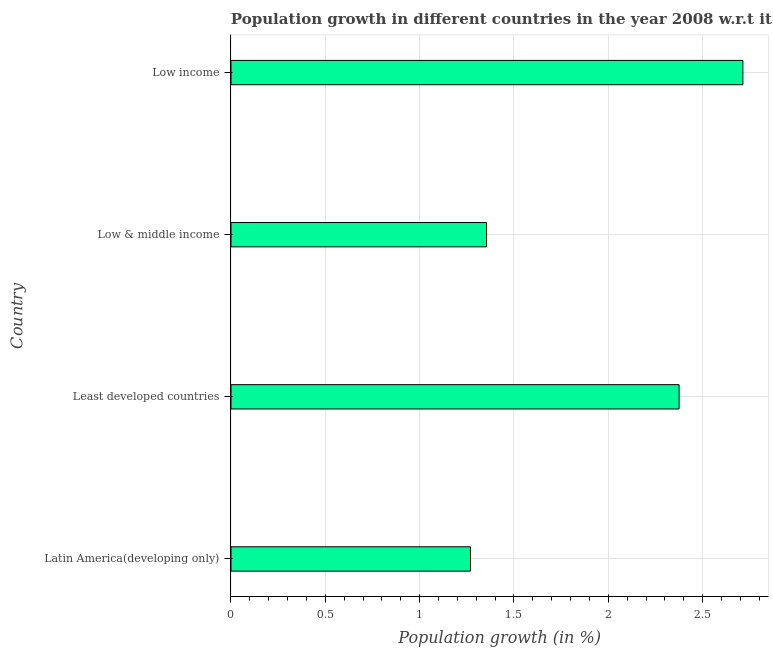Does the graph contain any zero values?
Offer a terse response. No. Does the graph contain grids?
Your answer should be very brief. Yes. What is the title of the graph?
Ensure brevity in your answer.  Population growth in different countries in the year 2008 w.r.t it's previous year. What is the label or title of the X-axis?
Give a very brief answer. Population growth (in %). What is the label or title of the Y-axis?
Keep it short and to the point. Country. What is the population growth in Low income?
Your response must be concise. 2.71. Across all countries, what is the maximum population growth?
Your answer should be very brief. 2.71. Across all countries, what is the minimum population growth?
Offer a terse response. 1.27. In which country was the population growth maximum?
Offer a very short reply. Low income. In which country was the population growth minimum?
Provide a succinct answer. Latin America(developing only). What is the sum of the population growth?
Provide a succinct answer. 7.71. What is the difference between the population growth in Latin America(developing only) and Low income?
Your response must be concise. -1.44. What is the average population growth per country?
Provide a succinct answer. 1.93. What is the median population growth?
Give a very brief answer. 1.86. What is the ratio of the population growth in Low & middle income to that in Low income?
Provide a succinct answer. 0.5. Is the population growth in Latin America(developing only) less than that in Low income?
Ensure brevity in your answer.  Yes. What is the difference between the highest and the second highest population growth?
Offer a terse response. 0.34. What is the difference between the highest and the lowest population growth?
Offer a terse response. 1.44. Are all the bars in the graph horizontal?
Provide a short and direct response. Yes. How many countries are there in the graph?
Your answer should be compact. 4. What is the difference between two consecutive major ticks on the X-axis?
Provide a short and direct response. 0.5. Are the values on the major ticks of X-axis written in scientific E-notation?
Ensure brevity in your answer.  No. What is the Population growth (in %) of Latin America(developing only)?
Keep it short and to the point. 1.27. What is the Population growth (in %) of Least developed countries?
Offer a terse response. 2.38. What is the Population growth (in %) of Low & middle income?
Your answer should be compact. 1.35. What is the Population growth (in %) in Low income?
Ensure brevity in your answer.  2.71. What is the difference between the Population growth (in %) in Latin America(developing only) and Least developed countries?
Give a very brief answer. -1.11. What is the difference between the Population growth (in %) in Latin America(developing only) and Low & middle income?
Offer a terse response. -0.09. What is the difference between the Population growth (in %) in Latin America(developing only) and Low income?
Your answer should be very brief. -1.44. What is the difference between the Population growth (in %) in Least developed countries and Low & middle income?
Your answer should be very brief. 1.02. What is the difference between the Population growth (in %) in Least developed countries and Low income?
Offer a terse response. -0.34. What is the difference between the Population growth (in %) in Low & middle income and Low income?
Your answer should be very brief. -1.36. What is the ratio of the Population growth (in %) in Latin America(developing only) to that in Least developed countries?
Your answer should be very brief. 0.53. What is the ratio of the Population growth (in %) in Latin America(developing only) to that in Low & middle income?
Ensure brevity in your answer.  0.94. What is the ratio of the Population growth (in %) in Latin America(developing only) to that in Low income?
Offer a terse response. 0.47. What is the ratio of the Population growth (in %) in Least developed countries to that in Low & middle income?
Provide a short and direct response. 1.75. What is the ratio of the Population growth (in %) in Low & middle income to that in Low income?
Your response must be concise. 0.5. 